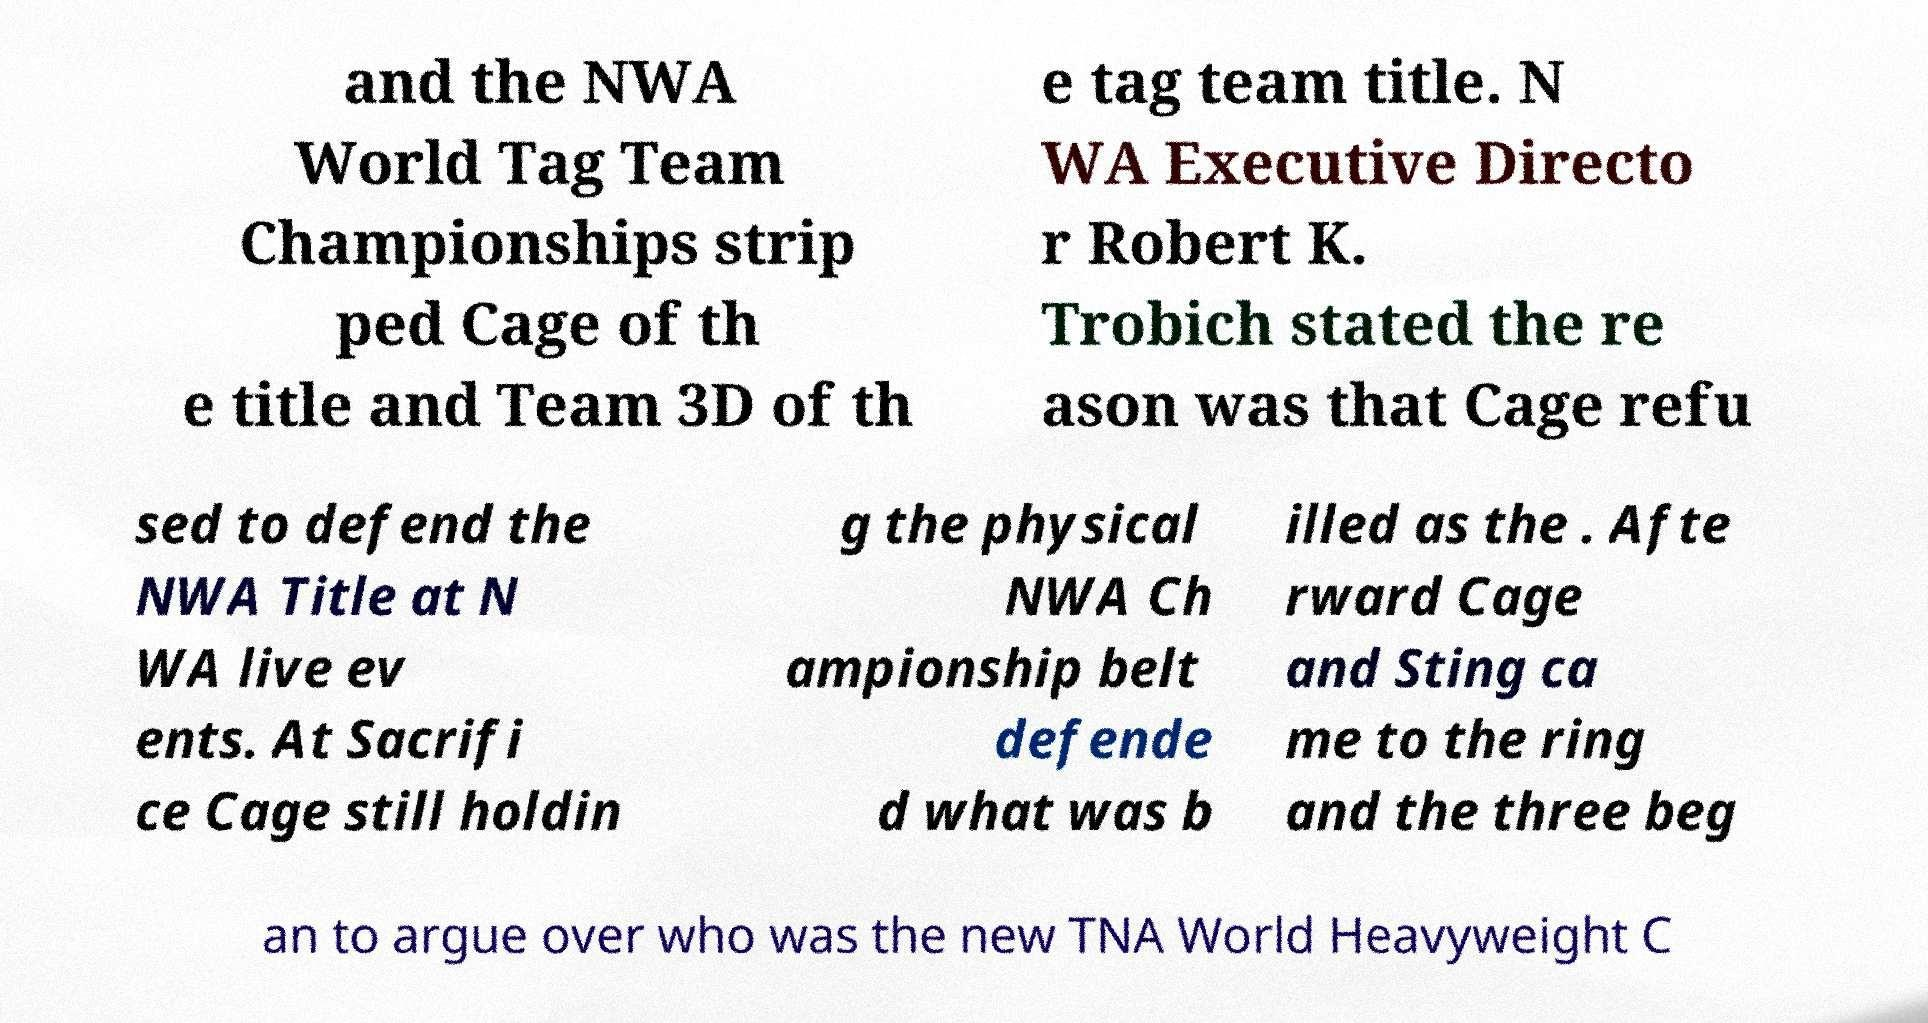I need the written content from this picture converted into text. Can you do that? and the NWA World Tag Team Championships strip ped Cage of th e title and Team 3D of th e tag team title. N WA Executive Directo r Robert K. Trobich stated the re ason was that Cage refu sed to defend the NWA Title at N WA live ev ents. At Sacrifi ce Cage still holdin g the physical NWA Ch ampionship belt defende d what was b illed as the . Afte rward Cage and Sting ca me to the ring and the three beg an to argue over who was the new TNA World Heavyweight C 